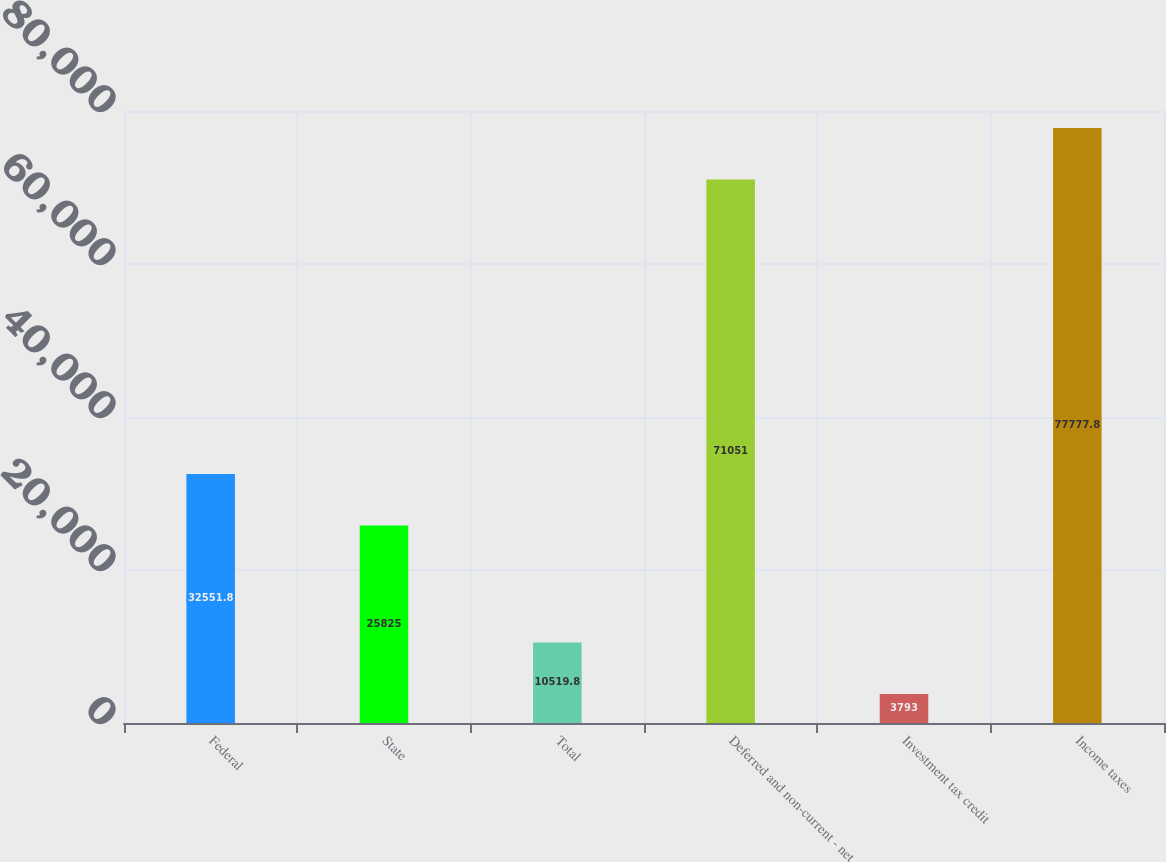<chart> <loc_0><loc_0><loc_500><loc_500><bar_chart><fcel>Federal<fcel>State<fcel>Total<fcel>Deferred and non-current - net<fcel>Investment tax credit<fcel>Income taxes<nl><fcel>32551.8<fcel>25825<fcel>10519.8<fcel>71051<fcel>3793<fcel>77777.8<nl></chart> 